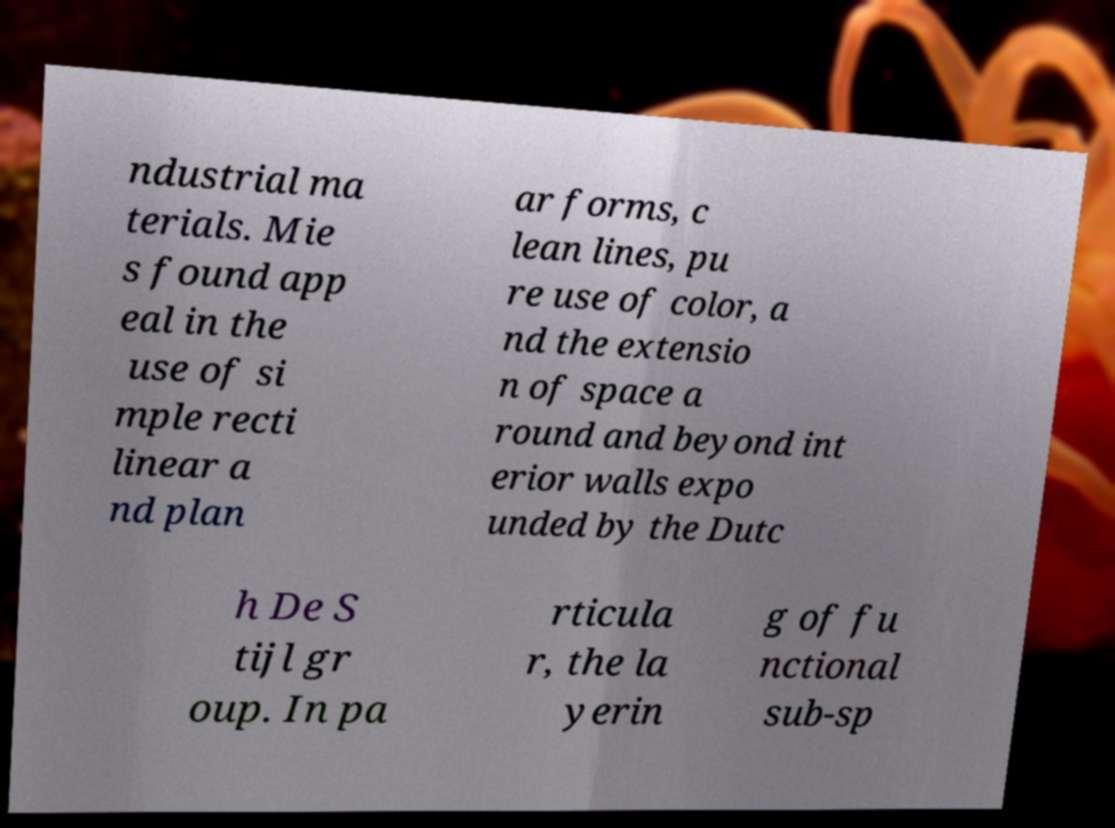Could you assist in decoding the text presented in this image and type it out clearly? ndustrial ma terials. Mie s found app eal in the use of si mple recti linear a nd plan ar forms, c lean lines, pu re use of color, a nd the extensio n of space a round and beyond int erior walls expo unded by the Dutc h De S tijl gr oup. In pa rticula r, the la yerin g of fu nctional sub-sp 